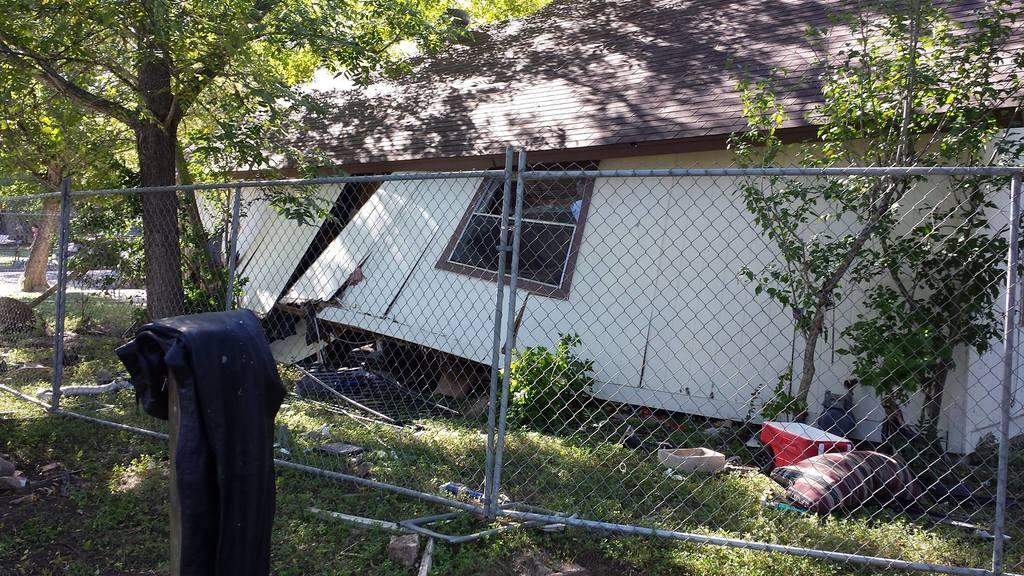What type of barrier can be seen in the image? There is a fence in the image. What type of building is present in the image? There is a house in the image. What type of vegetation is visible in the image? There are plants and trees in the image. What type of ground cover is present in the image? There is grass on the ground in the image. What object can be seen on the grass in the image? There is a red color box on the grass. What type of education is being offered in the image? There is no indication of education being offered in the image. What type of food is being served in the image? There is no food visible in the image. 